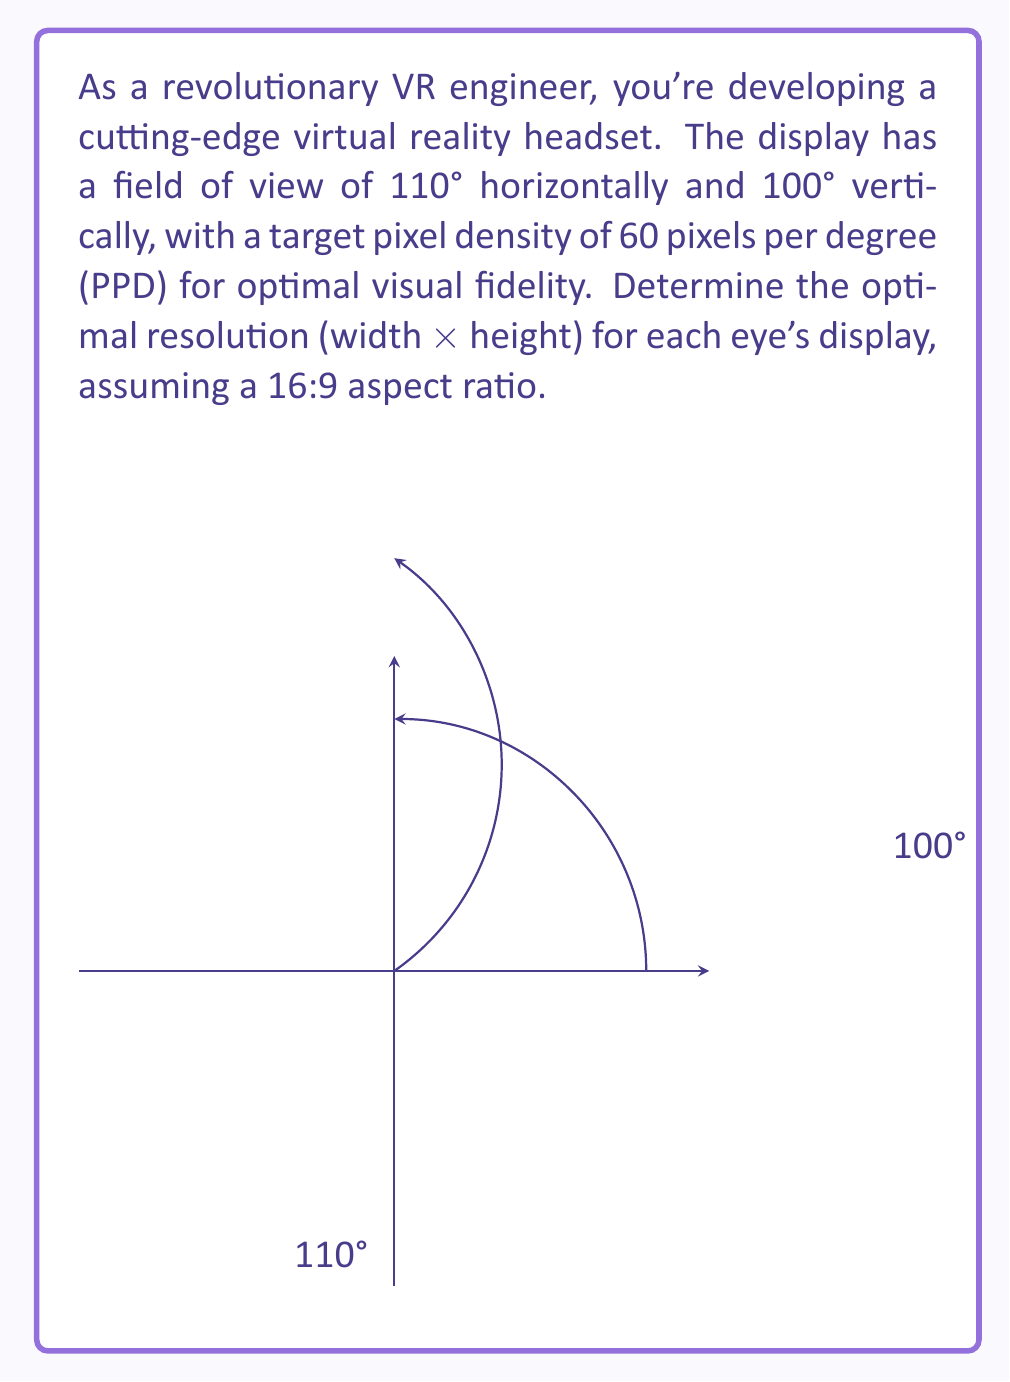What is the answer to this math problem? Let's approach this step-by-step:

1) First, we need to calculate the number of pixels for the horizontal and vertical dimensions:

   Horizontal pixels = 110° × 60 PPD = 6600 pixels
   Vertical pixels = 100° × 60 PPD = 6000 pixels

2) However, we need to maintain a 16:9 aspect ratio. Let's define our width as 16x and height as 9x, where x is a scaling factor:

   16x = 6600
   9x = 6000

3) Solving for x in both equations:

   x = 6600 ÷ 16 = 412.5
   x = 6000 ÷ 9 = 666.67

4) We need to choose the smaller x to ensure we don't exceed the calculated pixels in either dimension. So, x = 412.5

5) Now, let's calculate our final dimensions:

   Width = 16 × 412.5 = 6600 pixels
   Height = 9 × 412.5 = 3712.5 pixels

6) We need to round these to the nearest whole number:

   Width = 6600 pixels
   Height = 3713 pixels

Therefore, the optimal resolution for each eye's display is 6600 × 3713 pixels.
Answer: 6600 × 3713 pixels 